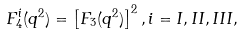<formula> <loc_0><loc_0><loc_500><loc_500>F _ { 4 } ^ { i } ( { q } ^ { 2 } ) = \left [ F _ { 3 } ( { q } ^ { 2 } ) \right ] ^ { 2 } , i = I , I I , I I I ,</formula> 